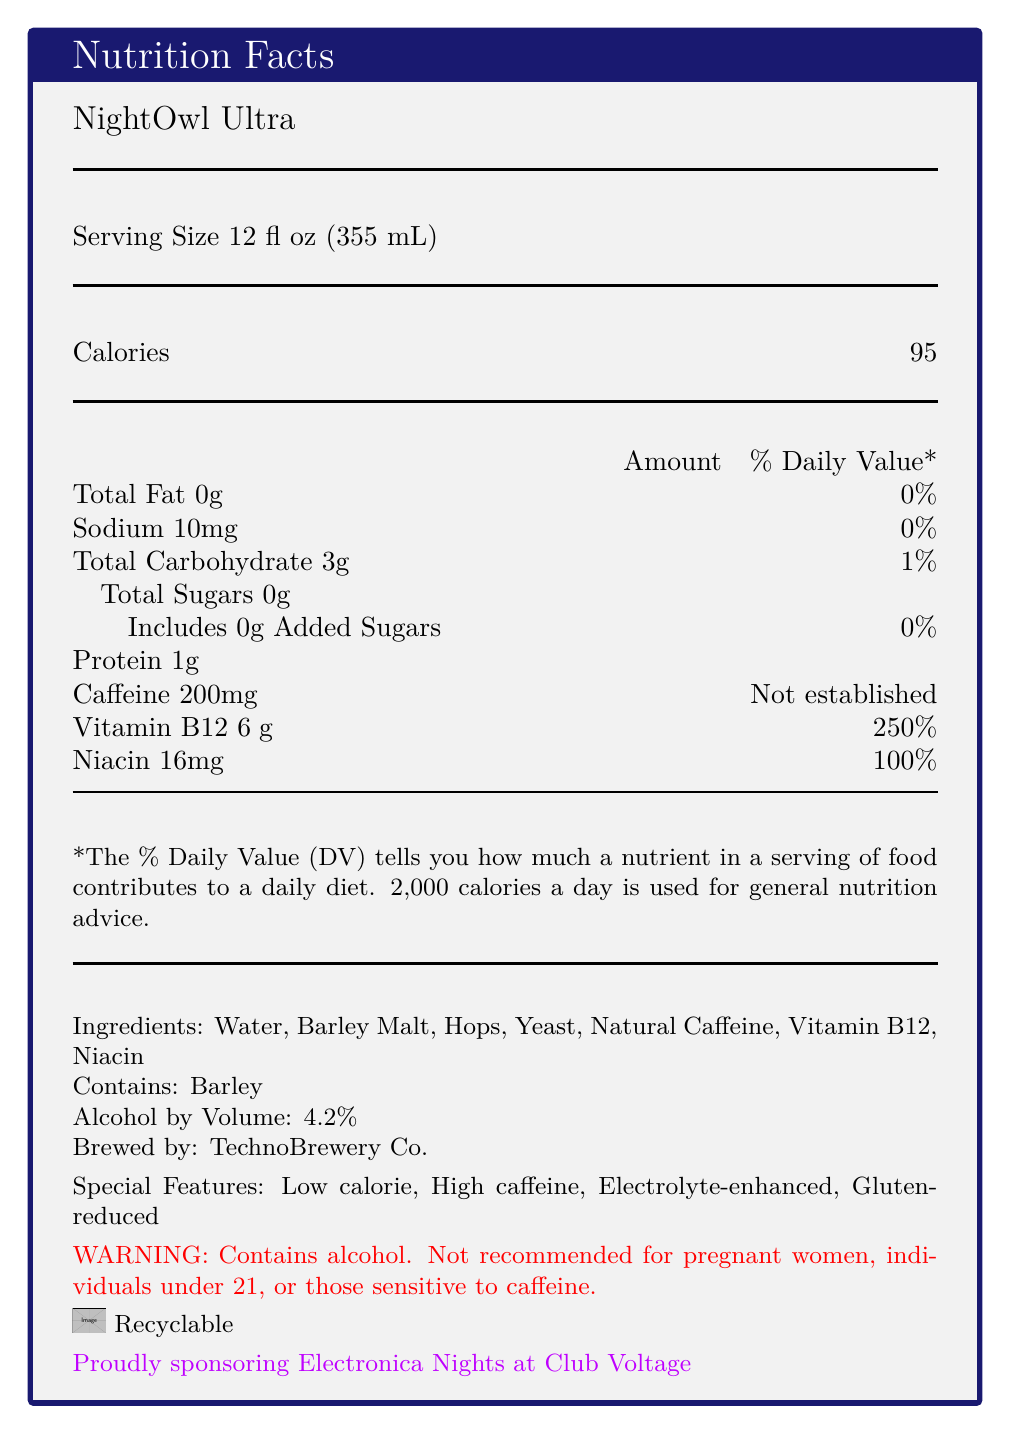what is the serving size of NightOwl Ultra? The document explicitly lists the serving size as "12 fl oz (355 mL)" in the nutrition facts section.
Answer: 12 fl oz (355 mL) what is the amount of calories per serving? The document states the calorie content as "95" per serving.
Answer: 95 how much sodium is in NightOwl Ultra? The sodium content is listed as "10mg" in the nutrition facts section.
Answer: 10mg what is the daily value percentage of Vitamin B12 in NightOwl Ultra? The document specifies that Vitamin B12 contributes to 250% of the daily value per serving.
Answer: 250% which ingredients are included in NightOwl Ultra? The ingredients are listed in the document under the "Ingredients" section.
Answer: Water, Barley Malt, Hops, Yeast, Natural Caffeine, Vitamin B12, Niacin what special features make NightOwl Ultra suitable for all-night dance events? The document highlights "Low calorie, High caffeine, Electrolyte-enhanced, Gluten-reduced" as special features.
Answer: Low calorie, High caffeine, Electrolyte-enhanced, Gluten-reduced how much alcohol does NightOwl Ultra contain? The document states "Alcohol by Volume: 4.2%".
Answer: 4.2% who brews NightOwl Ultra? The document mentions "Brewed by: TechnoBrewery Co."
Answer: TechnoBrewery Co. where is NightOwl Ultra sponsoring events? The document indicates, "Proudly sponsoring Electronica Nights at Club Voltage".
Answer: Electronica Nights at Club Voltage what caution is advised for certain individuals regarding NightOwl Ultra consumption? The warning section in the document advises: "Not recommended for pregnant women, individuals under 21, or those sensitive to caffeine."
Answer: Not recommended for pregnant women, individuals under 21, or those sensitive to caffeine how many grams of protein are in NightOwl Ultra? The document lists the protein content as "1g".
Answer: 1g what percentage of the daily value for niacin does a serving of NightOwl Ultra provide? The document mentions that Niacin contributes to "100%" of the daily value per serving.
Answer: 100% what visual elements are used in the document for better presentation? A. colors B. fonts C. images D. all of the above The document employs colors, different fonts, and images for better visual presentation.
Answer: D which of the following is a feature not mentioned for NightOwl Ultra? A. Gluten-free B. Gluten-reduced C. High caffeine D. Electrolyte-enhanced The document mentions "Gluten-reduced", but not "Gluten-free".
Answer: A is NightOwl Ultra a high-calorie beverage? The document highlights NightOwl Ultra as "Low calorie".
Answer: No is the daily value percentage for caffeine established on this label? The document specifies that the daily value percentage for caffeine is "Not established".
Answer: No summarize the document, emphasizing the main features and contents displayed. This summary includes key nutritional details, serving information, ingredients, special features, sponsors, and warnings to provide a comprehensive overview of the document's main ideas.
Answer: NightOwl Ultra is a low-calorie, high-caffeine beer brewed by TechnoBrewery Co. with special features including being electrolyte-enhanced and gluten-reduced. Each 12 fl oz serving contains 95 calories, 0g of fat, 10mg of sodium, 3g of carbohydrates, 200mg of caffeine, 1g of protein, 6μg of Vitamin B12 (250% DV), and 16mg of Niacin (100% DV). It is recommended for their Electronica Nights at Club Voltage sponsorship but not for pregnant women, those under 21, or sensitive to caffeine. The document also details the ingredients and alcohol content while highlighting recyclable packaging. what is the source of barley in the ingredient list? The document mentions barley as an ingredient but does not specify its source.
Answer: Cannot be determined 